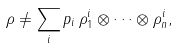Convert formula to latex. <formula><loc_0><loc_0><loc_500><loc_500>\rho \neq \sum _ { i } p _ { i } \, \rho _ { 1 } ^ { i } \otimes \cdots \otimes \rho _ { n } ^ { i } ,</formula> 